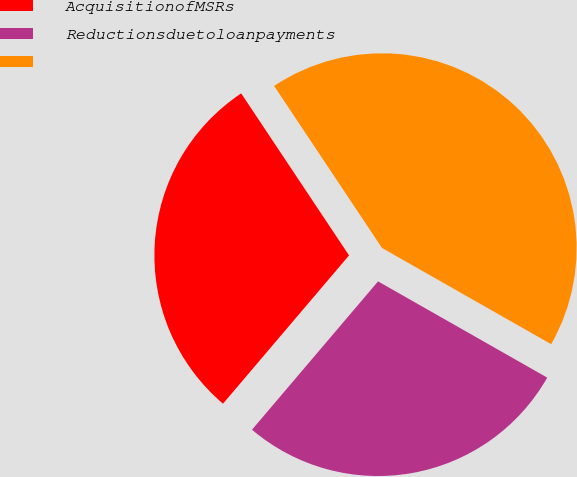Convert chart to OTSL. <chart><loc_0><loc_0><loc_500><loc_500><pie_chart><fcel>AcquisitionofMSRs<fcel>Reductionsduetoloanpayments<fcel>Unnamed: 2<nl><fcel>29.44%<fcel>27.98%<fcel>42.58%<nl></chart> 